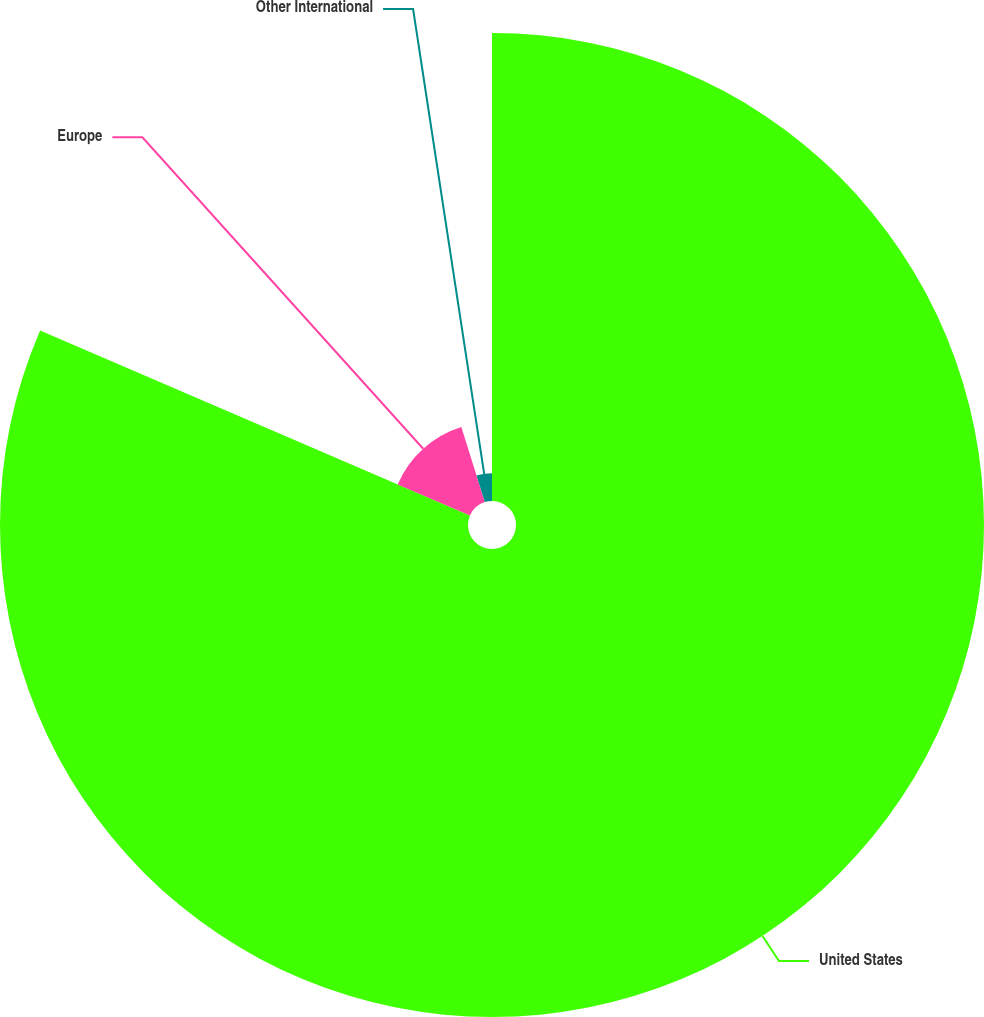<chart> <loc_0><loc_0><loc_500><loc_500><pie_chart><fcel>United States<fcel>Europe<fcel>Other International<nl><fcel>81.47%<fcel>13.7%<fcel>4.83%<nl></chart> 